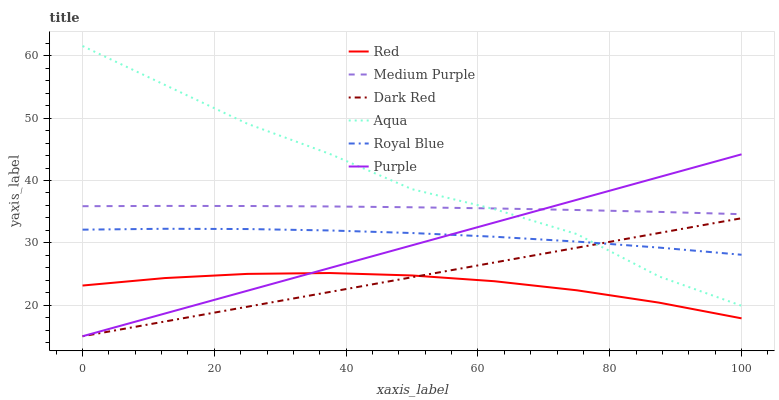Does Red have the minimum area under the curve?
Answer yes or no. Yes. Does Aqua have the maximum area under the curve?
Answer yes or no. Yes. Does Dark Red have the minimum area under the curve?
Answer yes or no. No. Does Dark Red have the maximum area under the curve?
Answer yes or no. No. Is Dark Red the smoothest?
Answer yes or no. Yes. Is Aqua the roughest?
Answer yes or no. Yes. Is Aqua the smoothest?
Answer yes or no. No. Is Dark Red the roughest?
Answer yes or no. No. Does Purple have the lowest value?
Answer yes or no. Yes. Does Aqua have the lowest value?
Answer yes or no. No. Does Aqua have the highest value?
Answer yes or no. Yes. Does Dark Red have the highest value?
Answer yes or no. No. Is Red less than Aqua?
Answer yes or no. Yes. Is Aqua greater than Red?
Answer yes or no. Yes. Does Dark Red intersect Red?
Answer yes or no. Yes. Is Dark Red less than Red?
Answer yes or no. No. Is Dark Red greater than Red?
Answer yes or no. No. Does Red intersect Aqua?
Answer yes or no. No. 